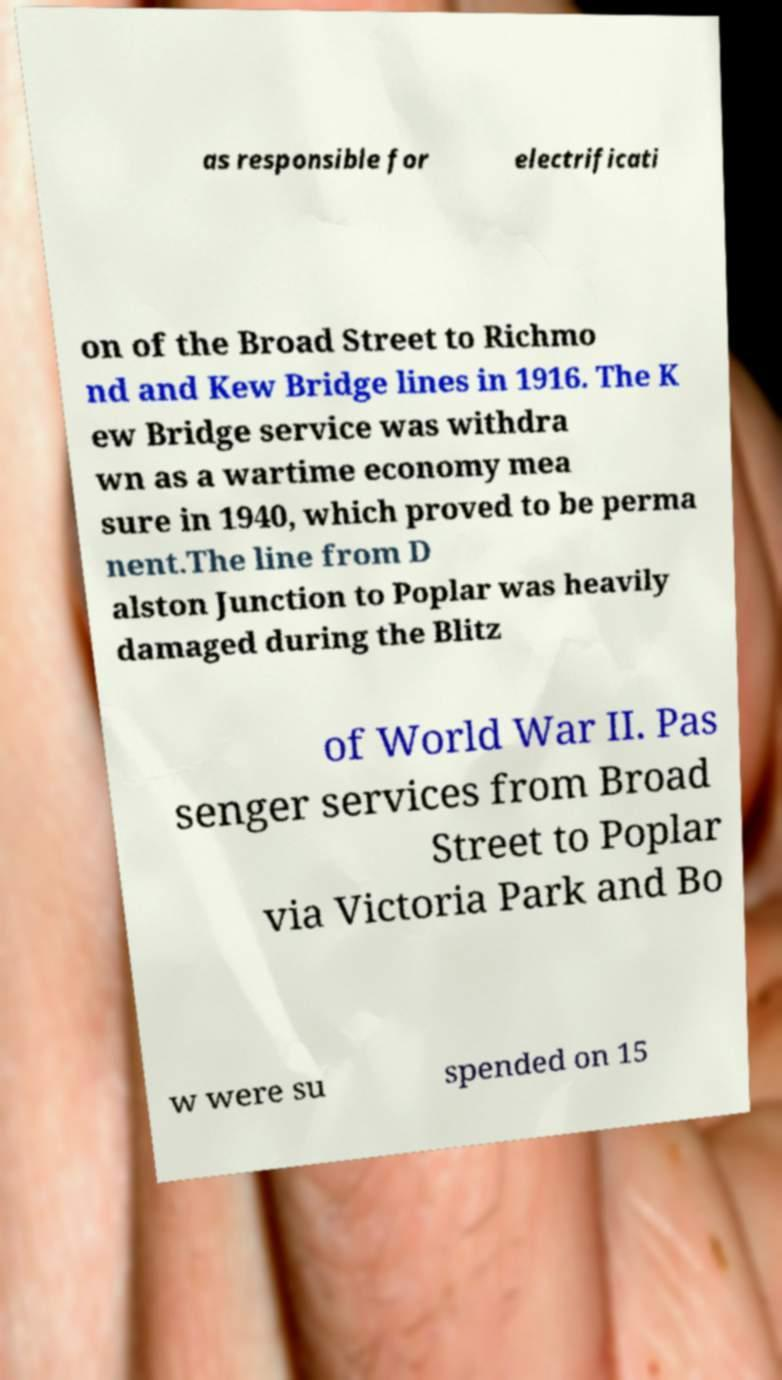Could you assist in decoding the text presented in this image and type it out clearly? as responsible for electrificati on of the Broad Street to Richmo nd and Kew Bridge lines in 1916. The K ew Bridge service was withdra wn as a wartime economy mea sure in 1940, which proved to be perma nent.The line from D alston Junction to Poplar was heavily damaged during the Blitz of World War II. Pas senger services from Broad Street to Poplar via Victoria Park and Bo w were su spended on 15 